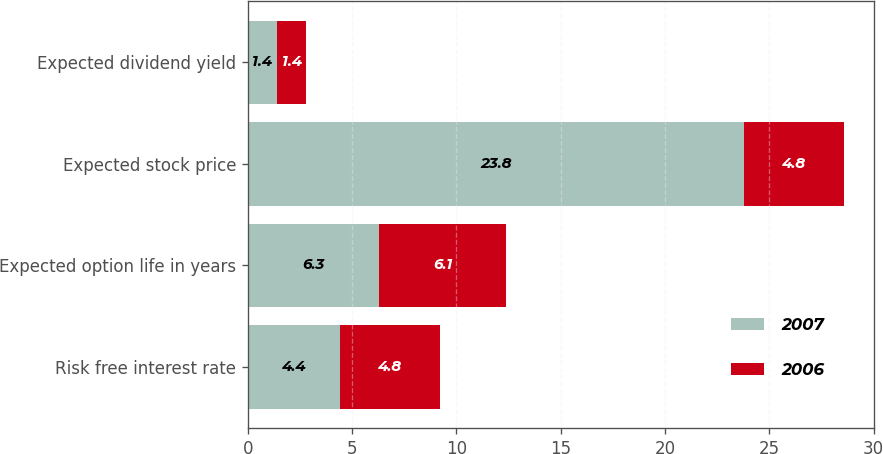Convert chart. <chart><loc_0><loc_0><loc_500><loc_500><stacked_bar_chart><ecel><fcel>Risk free interest rate<fcel>Expected option life in years<fcel>Expected stock price<fcel>Expected dividend yield<nl><fcel>2007<fcel>4.4<fcel>6.3<fcel>23.8<fcel>1.4<nl><fcel>2006<fcel>4.8<fcel>6.1<fcel>4.8<fcel>1.4<nl></chart> 